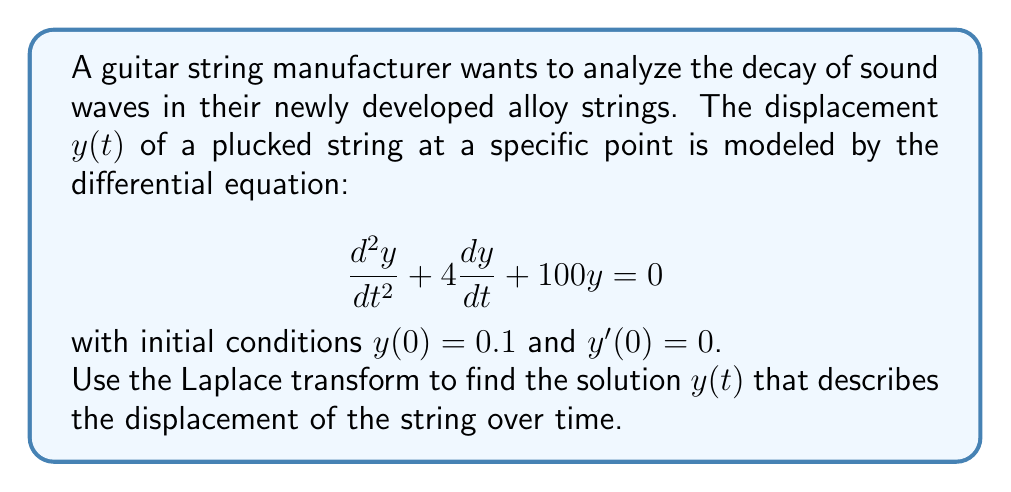Teach me how to tackle this problem. 1) First, let's take the Laplace transform of both sides of the differential equation:
   $$\mathcal{L}\{y''(t)\} + 4\mathcal{L}\{y'(t)\} + 100\mathcal{L}\{y(t)\} = 0$$

2) Using the properties of Laplace transforms:
   $$s^2Y(s) - sy(0) - y'(0) + 4[sY(s) - y(0)] + 100Y(s) = 0$$

3) Substitute the initial conditions $y(0) = 0.1$ and $y'(0) = 0$:
   $$s^2Y(s) - 0.1s + 4sY(s) - 0.4 + 100Y(s) = 0$$

4) Collect terms with $Y(s)$:
   $$(s^2 + 4s + 100)Y(s) = 0.1s + 0.4$$

5) Solve for $Y(s)$:
   $$Y(s) = \frac{0.1s + 0.4}{s^2 + 4s + 100}$$

6) This can be rewritten as:
   $$Y(s) = \frac{0.1s + 0.4}{(s+2)^2 + 96}$$

7) To find the inverse Laplace transform, we use the formula:
   $$\mathcal{L}^{-1}\{\frac{as+b}{(s+p)^2+q^2}\} = e^{-pt}(\frac{a}{2\sqrt{q^2}}sin(\sqrt{q^2}t) + \frac{ap+b}{\sqrt{q^2}}cos(\sqrt{q^2}t))$$

8) In our case, $a=0.1$, $b=0.4$, $p=2$, and $q^2=96$:
   $$y(t) = e^{-2t}(\frac{0.1}{2\sqrt{96}}sin(2\sqrt{6}t) + \frac{0.1(2)+0.4}{\sqrt{96}}cos(2\sqrt{6}t))$$

9) Simplify:
   $$y(t) = e^{-2t}(\frac{0.1}{4\sqrt{6}}sin(2\sqrt{6}t) + \frac{0.6}{4\sqrt{6}}cos(2\sqrt{6}t))$$
Answer: $y(t) = e^{-2t}(\frac{0.1}{4\sqrt{6}}sin(2\sqrt{6}t) + \frac{0.6}{4\sqrt{6}}cos(2\sqrt{6}t))$ 